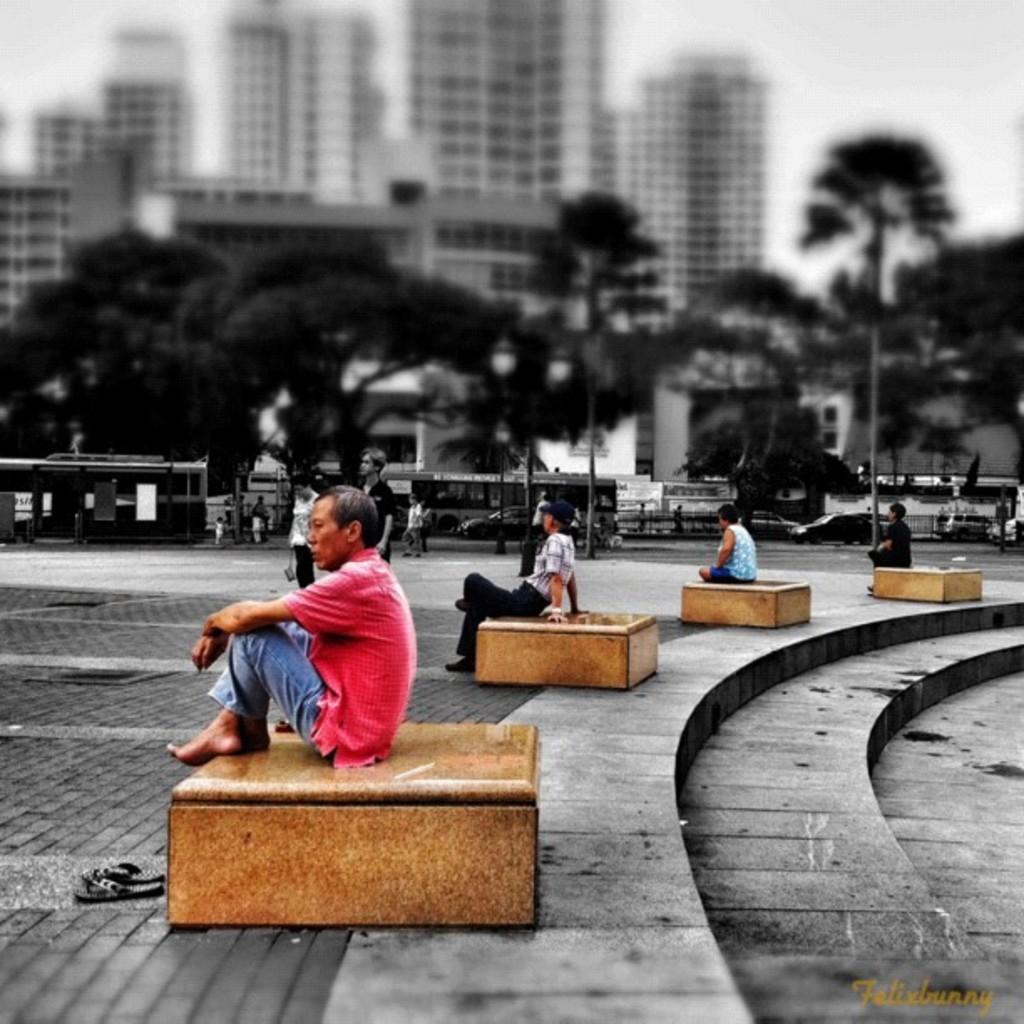Can you describe this image briefly? This is an edited image. I can see four people sitting and few people standing. In the background, there are trees, buildings and vehicles on the road. At the bottom right side of the image, I can see the watermark. 